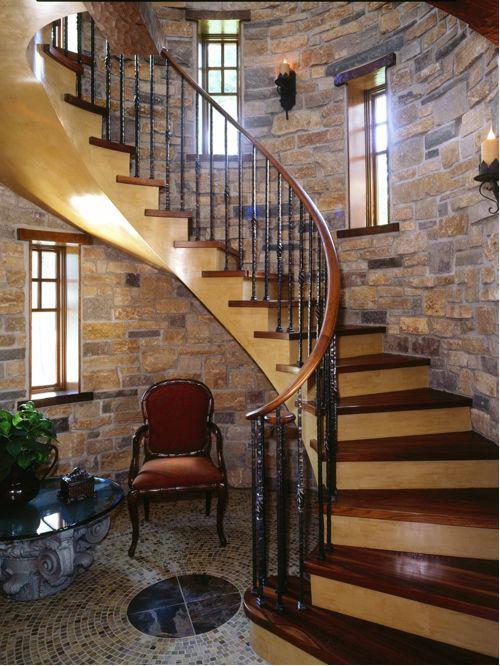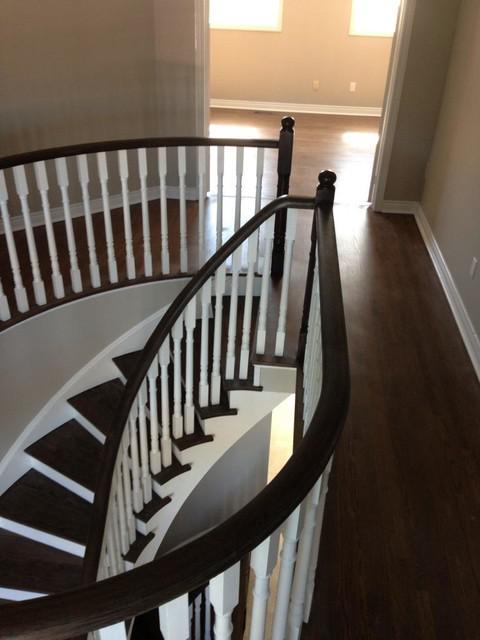The first image is the image on the left, the second image is the image on the right. Given the left and right images, does the statement "One image shows a curving staircase with black steps and handrails and white spindles that ascends to a second story." hold true? Answer yes or no. Yes. The first image is the image on the left, the second image is the image on the right. For the images displayed, is the sentence "Some stairs are curved." factually correct? Answer yes or no. Yes. 